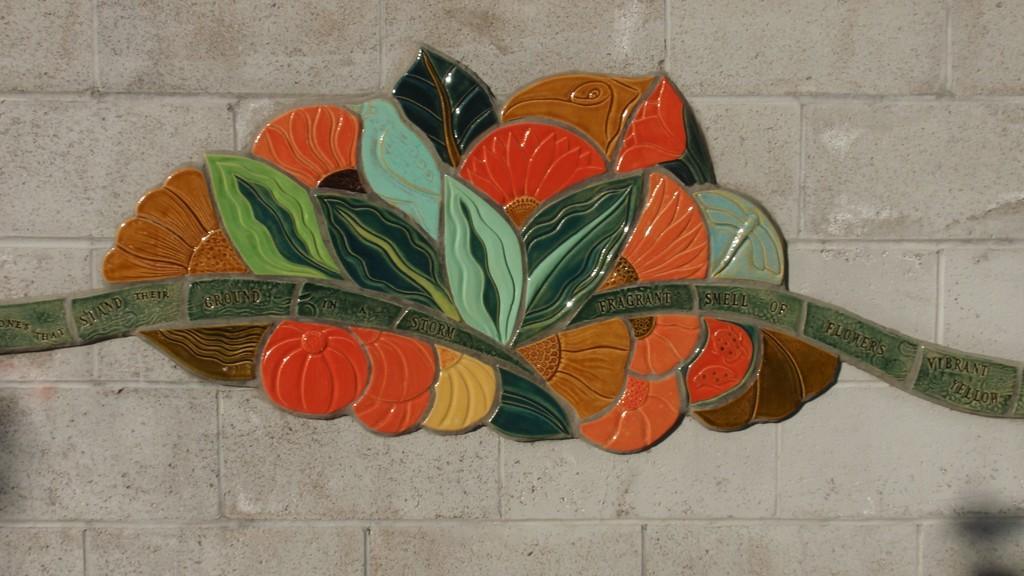In one or two sentences, can you explain what this image depicts? In this picture we can see a colorful object and a text on the stone wall. 